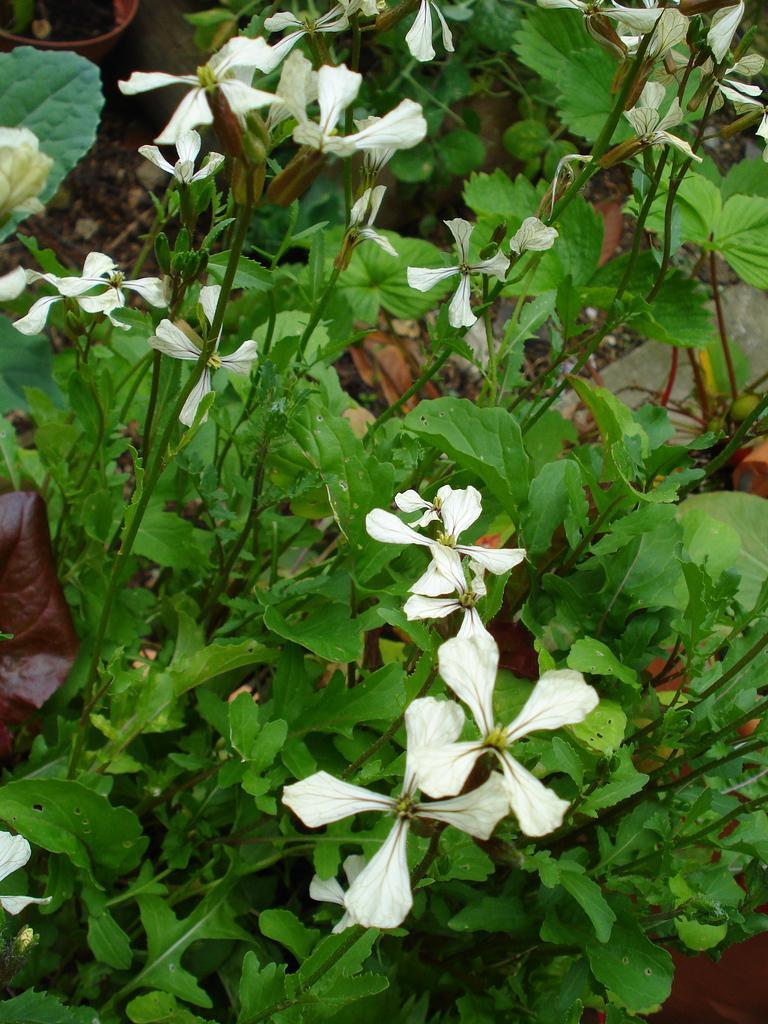Describe this image in one or two sentences. In this image we can see the white color flowers of the plant. We can also see the flower pots. 